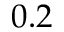<formula> <loc_0><loc_0><loc_500><loc_500>0 . 2</formula> 